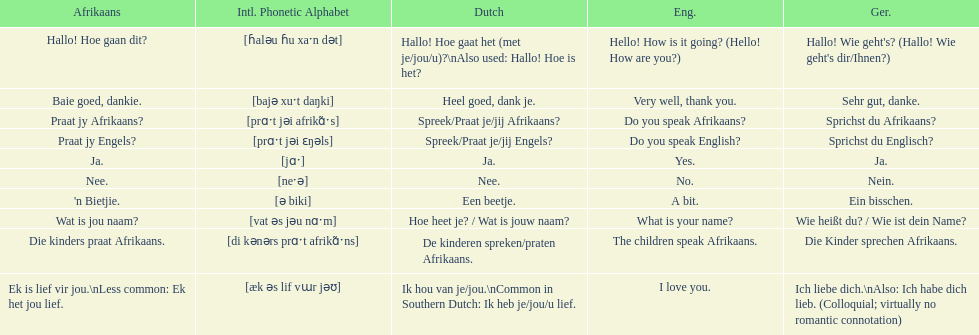What is the word for 'yes' in afrikaans? Ja. 